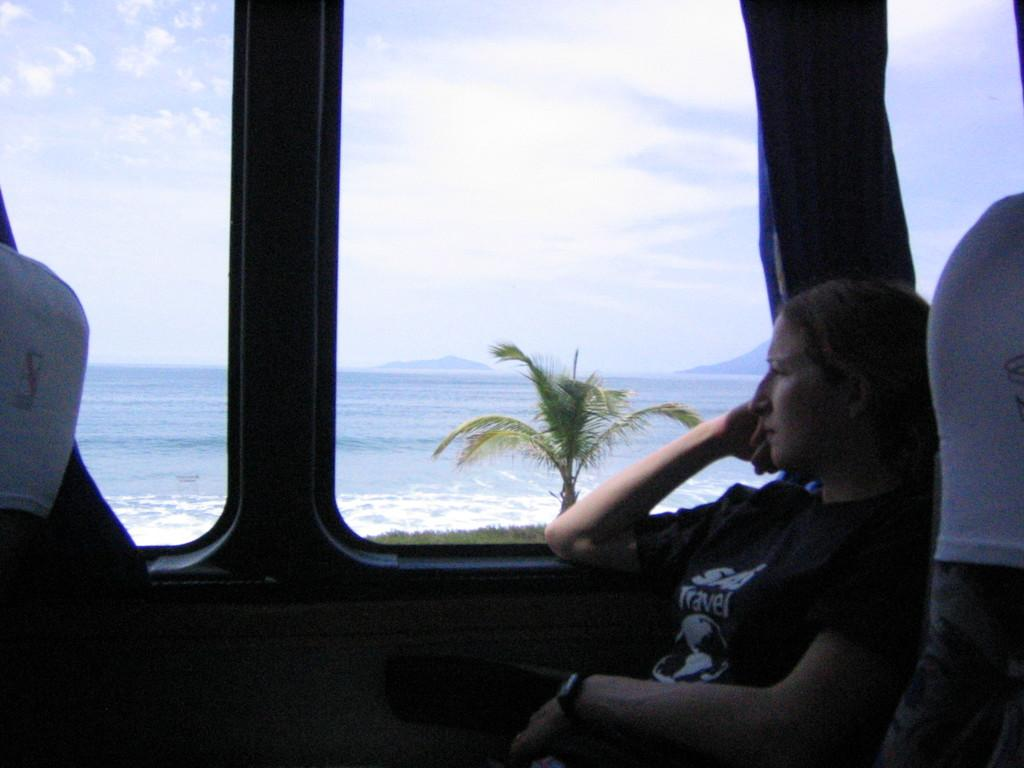Who is present in the image? There is a woman in the image. What is the woman wearing? The woman is wearing a black T-shirt. What is the woman doing in the image? The woman is sitting. What can be seen beside the woman? There is a glass window beside the woman. What is visible in the background of the image? There is a tree and water in the background of the image. What type of cake is the woman holding in the image? There is no cake present in the image; the woman is sitting and wearing a black T-shirt. 